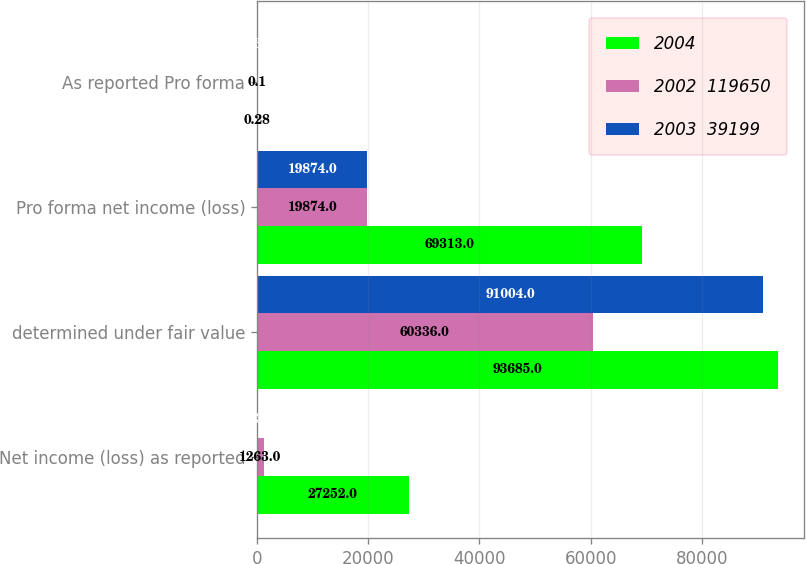<chart> <loc_0><loc_0><loc_500><loc_500><stacked_bar_chart><ecel><fcel>Net income (loss) as reported<fcel>determined under fair value<fcel>Pro forma net income (loss)<fcel>As reported Pro forma<nl><fcel>2004<fcel>27252<fcel>93685<fcel>69313<fcel>0.28<nl><fcel>2002  119650<fcel>1263<fcel>60336<fcel>19874<fcel>0.1<nl><fcel>2003  39199<fcel>253<fcel>91004<fcel>19874<fcel>0.34<nl></chart> 